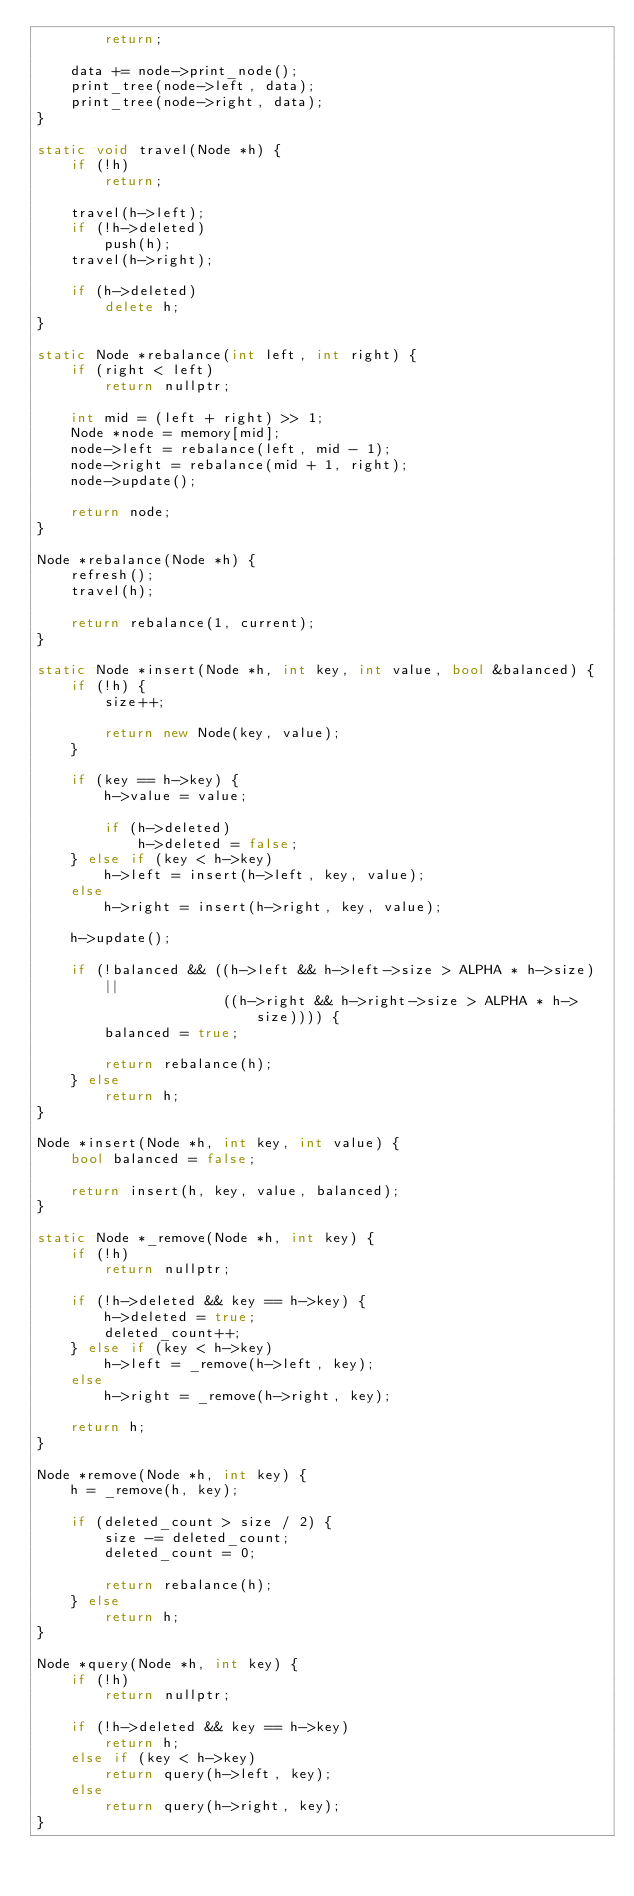Convert code to text. <code><loc_0><loc_0><loc_500><loc_500><_C++_>        return;

    data += node->print_node();
    print_tree(node->left, data);
    print_tree(node->right, data);
}

static void travel(Node *h) {
    if (!h)
        return;

    travel(h->left);
    if (!h->deleted)
        push(h);
    travel(h->right);

    if (h->deleted)
        delete h;
}

static Node *rebalance(int left, int right) {
    if (right < left)
        return nullptr;

    int mid = (left + right) >> 1;
    Node *node = memory[mid];
    node->left = rebalance(left, mid - 1);
    node->right = rebalance(mid + 1, right);
    node->update();

    return node;
}

Node *rebalance(Node *h) {
    refresh();
    travel(h);

    return rebalance(1, current);
}

static Node *insert(Node *h, int key, int value, bool &balanced) {
    if (!h) {
        size++;

        return new Node(key, value);
    }

    if (key == h->key) {
        h->value = value;

        if (h->deleted)
            h->deleted = false;
    } else if (key < h->key)
        h->left = insert(h->left, key, value);
    else
        h->right = insert(h->right, key, value);

    h->update();

    if (!balanced && ((h->left && h->left->size > ALPHA * h->size) ||
                      ((h->right && h->right->size > ALPHA * h->size)))) {
        balanced = true;

        return rebalance(h);
    } else
        return h;
}

Node *insert(Node *h, int key, int value) {
    bool balanced = false;

    return insert(h, key, value, balanced);
}

static Node *_remove(Node *h, int key) {
    if (!h)
        return nullptr;

    if (!h->deleted && key == h->key) {
        h->deleted = true;
        deleted_count++;
    } else if (key < h->key)
        h->left = _remove(h->left, key);
    else
        h->right = _remove(h->right, key);

    return h;
}

Node *remove(Node *h, int key) {
    h = _remove(h, key);

    if (deleted_count > size / 2) {
        size -= deleted_count;
        deleted_count = 0;

        return rebalance(h);
    } else
        return h;
}

Node *query(Node *h, int key) {
    if (!h)
        return nullptr;

    if (!h->deleted && key == h->key)
        return h;
    else if (key < h->key)
        return query(h->left, key);
    else
        return query(h->right, key);
}
</code> 